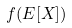Convert formula to latex. <formula><loc_0><loc_0><loc_500><loc_500>f ( E [ X ] )</formula> 